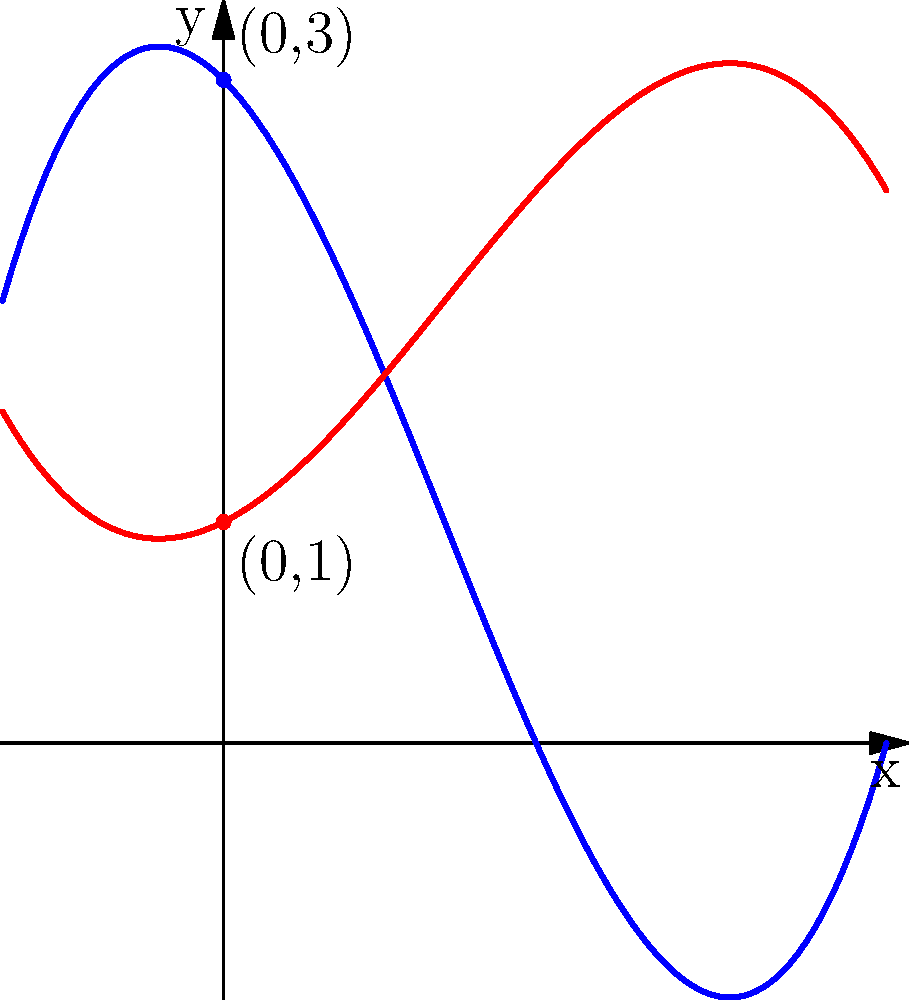You're designing a custom skateboard and want to create a unique curve for the deck. You've come up with two polynomial designs, represented by the blue and red curves in the graph. Design A (blue) is given by the function $f(x) = 0.5x^3 - 1.5x^2 - x + 3$, and Design B (red) is given by $g(x) = -0.25x^3 + 0.75x^2 + 0.5x + 1$. Which design has a higher y-intercept, and by how much? To solve this problem, we need to follow these steps:

1. Identify the y-intercept for each design:
   - The y-intercept is the y-value when x = 0.
   - For Design A: $f(0) = 0.5(0)^3 - 1.5(0)^2 - 0 + 3 = 3$
   - For Design B: $g(0) = -0.25(0)^3 + 0.75(0)^2 + 0.5(0) + 1 = 1$

2. Compare the y-intercepts:
   - Design A has a y-intercept of 3
   - Design B has a y-intercept of 1

3. Calculate the difference:
   - Difference = y-intercept of Design A - y-intercept of Design B
   - Difference = 3 - 1 = 2

Therefore, Design A has a higher y-intercept, and it is 2 units higher than Design B.
Answer: Design A; 2 units higher 